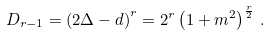Convert formula to latex. <formula><loc_0><loc_0><loc_500><loc_500>D _ { r - 1 } = \left ( 2 \Delta - d \right ) ^ { r } = 2 ^ { r } \left ( 1 + m ^ { 2 } \right ) ^ { \frac { r } { 2 } } \, .</formula> 